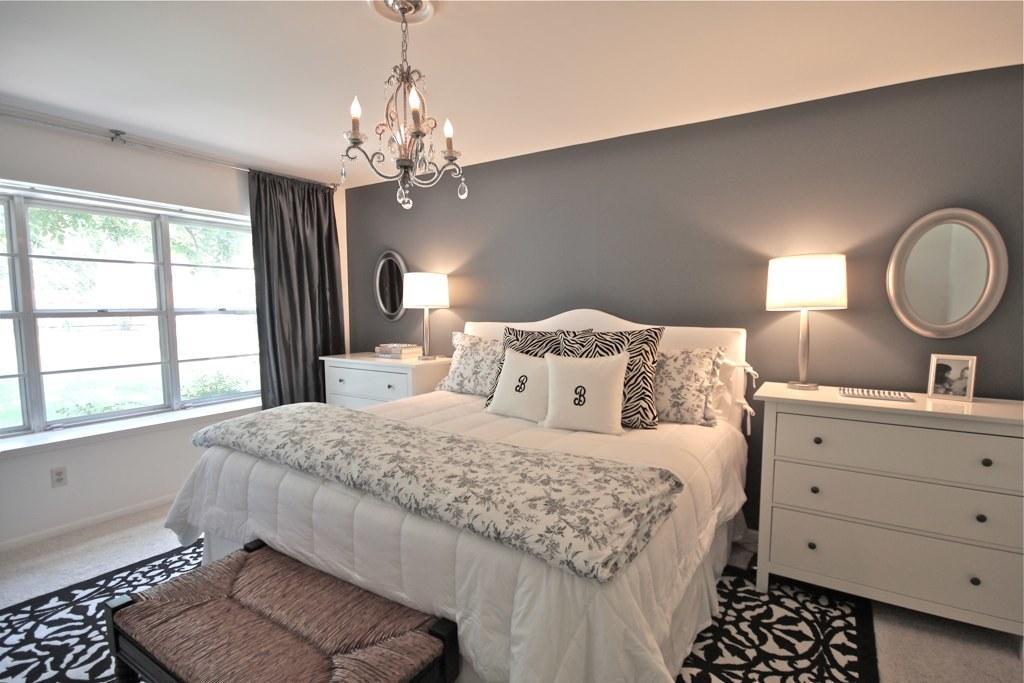Can you describe this image briefly? In this picture we can observe a bedroom. There is a bed on which we can observe pillows and a blanket. On the right side there are cupboards and a mirror fixed to the wall. There are two lamps. On the left side there are windows and black color curtain. In the background there are trees. 